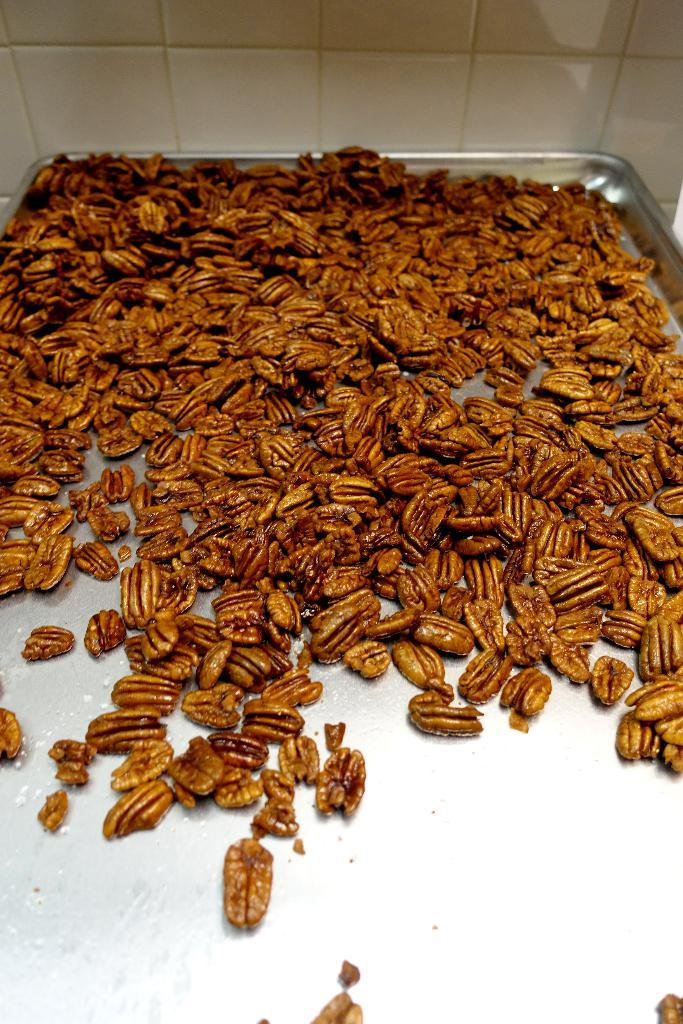What is on the tray in the image? There is food on a tray in the image. What can be seen behind the tray in the image? There is a wall visible behind the tray in the image. What type of texture can be seen on the pump in the image? There is no pump present in the image, so it is not possible to determine its texture. 